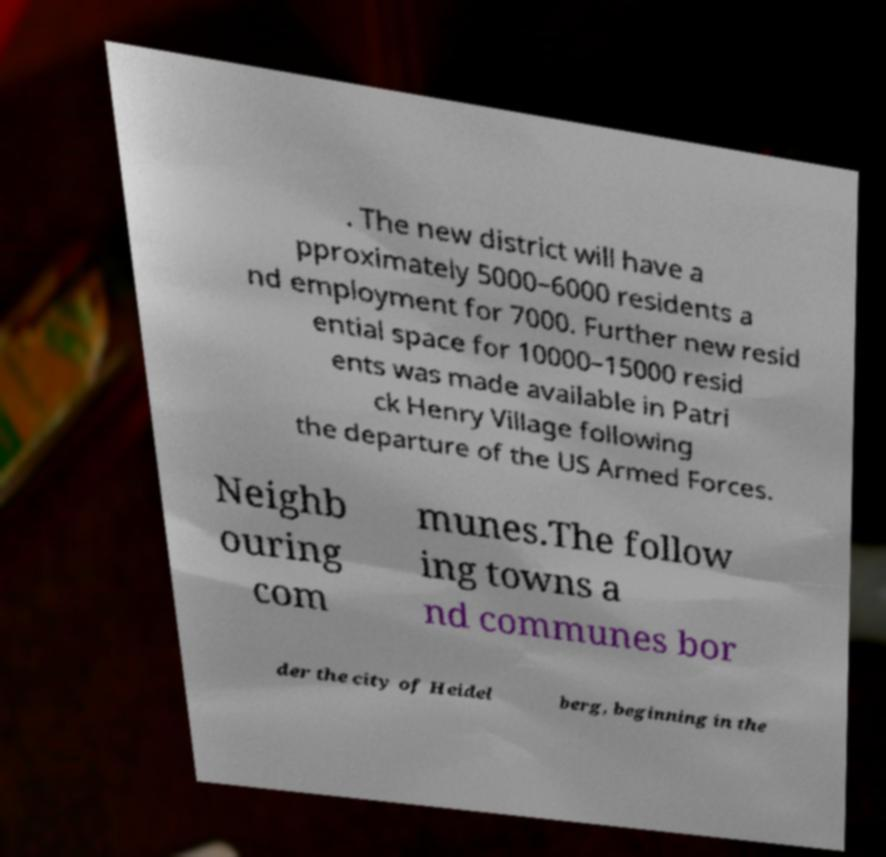Could you extract and type out the text from this image? . The new district will have a pproximately 5000–6000 residents a nd employment for 7000. Further new resid ential space for 10000–15000 resid ents was made available in Patri ck Henry Village following the departure of the US Armed Forces. Neighb ouring com munes.The follow ing towns a nd communes bor der the city of Heidel berg, beginning in the 